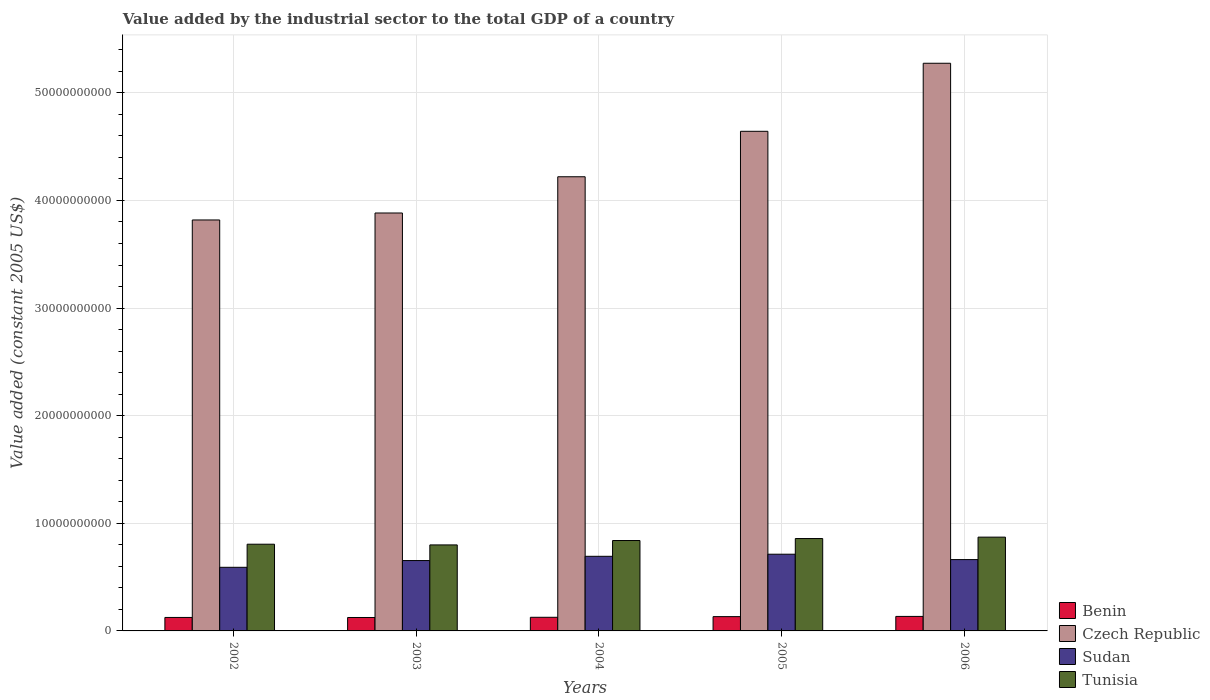How many different coloured bars are there?
Ensure brevity in your answer.  4. Are the number of bars on each tick of the X-axis equal?
Provide a succinct answer. Yes. How many bars are there on the 5th tick from the left?
Your answer should be compact. 4. How many bars are there on the 5th tick from the right?
Provide a succinct answer. 4. What is the label of the 2nd group of bars from the left?
Your answer should be compact. 2003. What is the value added by the industrial sector in Tunisia in 2003?
Provide a short and direct response. 7.99e+09. Across all years, what is the maximum value added by the industrial sector in Benin?
Offer a very short reply. 1.35e+09. Across all years, what is the minimum value added by the industrial sector in Benin?
Offer a very short reply. 1.25e+09. In which year was the value added by the industrial sector in Czech Republic maximum?
Give a very brief answer. 2006. What is the total value added by the industrial sector in Czech Republic in the graph?
Offer a terse response. 2.18e+11. What is the difference between the value added by the industrial sector in Tunisia in 2003 and that in 2005?
Provide a short and direct response. -5.93e+08. What is the difference between the value added by the industrial sector in Benin in 2005 and the value added by the industrial sector in Czech Republic in 2004?
Your answer should be compact. -4.09e+1. What is the average value added by the industrial sector in Sudan per year?
Make the answer very short. 6.63e+09. In the year 2005, what is the difference between the value added by the industrial sector in Sudan and value added by the industrial sector in Benin?
Provide a short and direct response. 5.80e+09. In how many years, is the value added by the industrial sector in Benin greater than 46000000000 US$?
Your answer should be very brief. 0. What is the ratio of the value added by the industrial sector in Benin in 2003 to that in 2006?
Ensure brevity in your answer.  0.93. Is the value added by the industrial sector in Czech Republic in 2003 less than that in 2004?
Give a very brief answer. Yes. What is the difference between the highest and the second highest value added by the industrial sector in Tunisia?
Your response must be concise. 1.30e+08. What is the difference between the highest and the lowest value added by the industrial sector in Benin?
Offer a very short reply. 1.00e+08. In how many years, is the value added by the industrial sector in Sudan greater than the average value added by the industrial sector in Sudan taken over all years?
Give a very brief answer. 3. Is the sum of the value added by the industrial sector in Sudan in 2003 and 2006 greater than the maximum value added by the industrial sector in Tunisia across all years?
Your response must be concise. Yes. Is it the case that in every year, the sum of the value added by the industrial sector in Tunisia and value added by the industrial sector in Benin is greater than the sum of value added by the industrial sector in Czech Republic and value added by the industrial sector in Sudan?
Your answer should be compact. Yes. What does the 3rd bar from the left in 2002 represents?
Provide a succinct answer. Sudan. What does the 4th bar from the right in 2002 represents?
Provide a short and direct response. Benin. Is it the case that in every year, the sum of the value added by the industrial sector in Tunisia and value added by the industrial sector in Benin is greater than the value added by the industrial sector in Czech Republic?
Your answer should be compact. No. How many bars are there?
Offer a very short reply. 20. How many years are there in the graph?
Your answer should be very brief. 5. What is the difference between two consecutive major ticks on the Y-axis?
Provide a short and direct response. 1.00e+1. Are the values on the major ticks of Y-axis written in scientific E-notation?
Offer a terse response. No. Does the graph contain any zero values?
Your answer should be very brief. No. How are the legend labels stacked?
Provide a short and direct response. Vertical. What is the title of the graph?
Ensure brevity in your answer.  Value added by the industrial sector to the total GDP of a country. Does "Nicaragua" appear as one of the legend labels in the graph?
Keep it short and to the point. No. What is the label or title of the X-axis?
Make the answer very short. Years. What is the label or title of the Y-axis?
Provide a succinct answer. Value added (constant 2005 US$). What is the Value added (constant 2005 US$) in Benin in 2002?
Provide a succinct answer. 1.25e+09. What is the Value added (constant 2005 US$) of Czech Republic in 2002?
Offer a terse response. 3.82e+1. What is the Value added (constant 2005 US$) of Sudan in 2002?
Provide a succinct answer. 5.91e+09. What is the Value added (constant 2005 US$) of Tunisia in 2002?
Your answer should be very brief. 8.06e+09. What is the Value added (constant 2005 US$) in Benin in 2003?
Your response must be concise. 1.25e+09. What is the Value added (constant 2005 US$) in Czech Republic in 2003?
Ensure brevity in your answer.  3.88e+1. What is the Value added (constant 2005 US$) in Sudan in 2003?
Your answer should be compact. 6.54e+09. What is the Value added (constant 2005 US$) of Tunisia in 2003?
Your answer should be compact. 7.99e+09. What is the Value added (constant 2005 US$) in Benin in 2004?
Ensure brevity in your answer.  1.27e+09. What is the Value added (constant 2005 US$) of Czech Republic in 2004?
Keep it short and to the point. 4.22e+1. What is the Value added (constant 2005 US$) of Sudan in 2004?
Make the answer very short. 6.93e+09. What is the Value added (constant 2005 US$) in Tunisia in 2004?
Provide a succinct answer. 8.40e+09. What is the Value added (constant 2005 US$) in Benin in 2005?
Give a very brief answer. 1.33e+09. What is the Value added (constant 2005 US$) in Czech Republic in 2005?
Give a very brief answer. 4.64e+1. What is the Value added (constant 2005 US$) of Sudan in 2005?
Give a very brief answer. 7.13e+09. What is the Value added (constant 2005 US$) in Tunisia in 2005?
Your answer should be very brief. 8.59e+09. What is the Value added (constant 2005 US$) of Benin in 2006?
Offer a terse response. 1.35e+09. What is the Value added (constant 2005 US$) in Czech Republic in 2006?
Provide a short and direct response. 5.28e+1. What is the Value added (constant 2005 US$) in Sudan in 2006?
Your answer should be compact. 6.63e+09. What is the Value added (constant 2005 US$) of Tunisia in 2006?
Keep it short and to the point. 8.72e+09. Across all years, what is the maximum Value added (constant 2005 US$) of Benin?
Ensure brevity in your answer.  1.35e+09. Across all years, what is the maximum Value added (constant 2005 US$) in Czech Republic?
Offer a very short reply. 5.28e+1. Across all years, what is the maximum Value added (constant 2005 US$) in Sudan?
Make the answer very short. 7.13e+09. Across all years, what is the maximum Value added (constant 2005 US$) of Tunisia?
Provide a short and direct response. 8.72e+09. Across all years, what is the minimum Value added (constant 2005 US$) in Benin?
Your answer should be compact. 1.25e+09. Across all years, what is the minimum Value added (constant 2005 US$) of Czech Republic?
Provide a succinct answer. 3.82e+1. Across all years, what is the minimum Value added (constant 2005 US$) of Sudan?
Your answer should be compact. 5.91e+09. Across all years, what is the minimum Value added (constant 2005 US$) of Tunisia?
Make the answer very short. 7.99e+09. What is the total Value added (constant 2005 US$) in Benin in the graph?
Make the answer very short. 6.44e+09. What is the total Value added (constant 2005 US$) of Czech Republic in the graph?
Offer a very short reply. 2.18e+11. What is the total Value added (constant 2005 US$) in Sudan in the graph?
Your response must be concise. 3.31e+1. What is the total Value added (constant 2005 US$) in Tunisia in the graph?
Your answer should be compact. 4.18e+1. What is the difference between the Value added (constant 2005 US$) in Benin in 2002 and that in 2003?
Your answer should be very brief. 4.56e+06. What is the difference between the Value added (constant 2005 US$) in Czech Republic in 2002 and that in 2003?
Give a very brief answer. -6.47e+08. What is the difference between the Value added (constant 2005 US$) of Sudan in 2002 and that in 2003?
Your answer should be very brief. -6.27e+08. What is the difference between the Value added (constant 2005 US$) in Tunisia in 2002 and that in 2003?
Make the answer very short. 6.48e+07. What is the difference between the Value added (constant 2005 US$) of Benin in 2002 and that in 2004?
Give a very brief answer. -1.42e+07. What is the difference between the Value added (constant 2005 US$) in Czech Republic in 2002 and that in 2004?
Offer a very short reply. -4.02e+09. What is the difference between the Value added (constant 2005 US$) in Sudan in 2002 and that in 2004?
Your answer should be very brief. -1.02e+09. What is the difference between the Value added (constant 2005 US$) of Tunisia in 2002 and that in 2004?
Provide a succinct answer. -3.43e+08. What is the difference between the Value added (constant 2005 US$) in Benin in 2002 and that in 2005?
Give a very brief answer. -7.57e+07. What is the difference between the Value added (constant 2005 US$) of Czech Republic in 2002 and that in 2005?
Your answer should be very brief. -8.24e+09. What is the difference between the Value added (constant 2005 US$) in Sudan in 2002 and that in 2005?
Offer a very short reply. -1.22e+09. What is the difference between the Value added (constant 2005 US$) of Tunisia in 2002 and that in 2005?
Make the answer very short. -5.28e+08. What is the difference between the Value added (constant 2005 US$) in Benin in 2002 and that in 2006?
Keep it short and to the point. -9.55e+07. What is the difference between the Value added (constant 2005 US$) of Czech Republic in 2002 and that in 2006?
Keep it short and to the point. -1.46e+1. What is the difference between the Value added (constant 2005 US$) of Sudan in 2002 and that in 2006?
Ensure brevity in your answer.  -7.18e+08. What is the difference between the Value added (constant 2005 US$) in Tunisia in 2002 and that in 2006?
Offer a very short reply. -6.58e+08. What is the difference between the Value added (constant 2005 US$) of Benin in 2003 and that in 2004?
Your response must be concise. -1.88e+07. What is the difference between the Value added (constant 2005 US$) of Czech Republic in 2003 and that in 2004?
Ensure brevity in your answer.  -3.37e+09. What is the difference between the Value added (constant 2005 US$) of Sudan in 2003 and that in 2004?
Provide a short and direct response. -3.95e+08. What is the difference between the Value added (constant 2005 US$) in Tunisia in 2003 and that in 2004?
Provide a short and direct response. -4.08e+08. What is the difference between the Value added (constant 2005 US$) in Benin in 2003 and that in 2005?
Keep it short and to the point. -8.03e+07. What is the difference between the Value added (constant 2005 US$) of Czech Republic in 2003 and that in 2005?
Your answer should be very brief. -7.59e+09. What is the difference between the Value added (constant 2005 US$) in Sudan in 2003 and that in 2005?
Keep it short and to the point. -5.90e+08. What is the difference between the Value added (constant 2005 US$) in Tunisia in 2003 and that in 2005?
Provide a short and direct response. -5.93e+08. What is the difference between the Value added (constant 2005 US$) of Benin in 2003 and that in 2006?
Give a very brief answer. -1.00e+08. What is the difference between the Value added (constant 2005 US$) of Czech Republic in 2003 and that in 2006?
Your response must be concise. -1.39e+1. What is the difference between the Value added (constant 2005 US$) in Sudan in 2003 and that in 2006?
Offer a terse response. -9.01e+07. What is the difference between the Value added (constant 2005 US$) in Tunisia in 2003 and that in 2006?
Offer a very short reply. -7.23e+08. What is the difference between the Value added (constant 2005 US$) in Benin in 2004 and that in 2005?
Keep it short and to the point. -6.15e+07. What is the difference between the Value added (constant 2005 US$) in Czech Republic in 2004 and that in 2005?
Your response must be concise. -4.22e+09. What is the difference between the Value added (constant 2005 US$) in Sudan in 2004 and that in 2005?
Provide a short and direct response. -1.94e+08. What is the difference between the Value added (constant 2005 US$) in Tunisia in 2004 and that in 2005?
Provide a short and direct response. -1.85e+08. What is the difference between the Value added (constant 2005 US$) in Benin in 2004 and that in 2006?
Offer a very short reply. -8.12e+07. What is the difference between the Value added (constant 2005 US$) in Czech Republic in 2004 and that in 2006?
Offer a very short reply. -1.05e+1. What is the difference between the Value added (constant 2005 US$) in Sudan in 2004 and that in 2006?
Provide a succinct answer. 3.05e+08. What is the difference between the Value added (constant 2005 US$) in Tunisia in 2004 and that in 2006?
Provide a short and direct response. -3.15e+08. What is the difference between the Value added (constant 2005 US$) of Benin in 2005 and that in 2006?
Provide a short and direct response. -1.97e+07. What is the difference between the Value added (constant 2005 US$) of Czech Republic in 2005 and that in 2006?
Provide a succinct answer. -6.32e+09. What is the difference between the Value added (constant 2005 US$) of Sudan in 2005 and that in 2006?
Ensure brevity in your answer.  5.00e+08. What is the difference between the Value added (constant 2005 US$) of Tunisia in 2005 and that in 2006?
Provide a succinct answer. -1.30e+08. What is the difference between the Value added (constant 2005 US$) of Benin in 2002 and the Value added (constant 2005 US$) of Czech Republic in 2003?
Your answer should be very brief. -3.76e+1. What is the difference between the Value added (constant 2005 US$) of Benin in 2002 and the Value added (constant 2005 US$) of Sudan in 2003?
Provide a short and direct response. -5.29e+09. What is the difference between the Value added (constant 2005 US$) of Benin in 2002 and the Value added (constant 2005 US$) of Tunisia in 2003?
Provide a short and direct response. -6.74e+09. What is the difference between the Value added (constant 2005 US$) of Czech Republic in 2002 and the Value added (constant 2005 US$) of Sudan in 2003?
Your answer should be compact. 3.17e+1. What is the difference between the Value added (constant 2005 US$) of Czech Republic in 2002 and the Value added (constant 2005 US$) of Tunisia in 2003?
Give a very brief answer. 3.02e+1. What is the difference between the Value added (constant 2005 US$) of Sudan in 2002 and the Value added (constant 2005 US$) of Tunisia in 2003?
Give a very brief answer. -2.08e+09. What is the difference between the Value added (constant 2005 US$) in Benin in 2002 and the Value added (constant 2005 US$) in Czech Republic in 2004?
Your answer should be very brief. -4.10e+1. What is the difference between the Value added (constant 2005 US$) in Benin in 2002 and the Value added (constant 2005 US$) in Sudan in 2004?
Offer a very short reply. -5.68e+09. What is the difference between the Value added (constant 2005 US$) in Benin in 2002 and the Value added (constant 2005 US$) in Tunisia in 2004?
Ensure brevity in your answer.  -7.15e+09. What is the difference between the Value added (constant 2005 US$) of Czech Republic in 2002 and the Value added (constant 2005 US$) of Sudan in 2004?
Ensure brevity in your answer.  3.13e+1. What is the difference between the Value added (constant 2005 US$) in Czech Republic in 2002 and the Value added (constant 2005 US$) in Tunisia in 2004?
Your response must be concise. 2.98e+1. What is the difference between the Value added (constant 2005 US$) of Sudan in 2002 and the Value added (constant 2005 US$) of Tunisia in 2004?
Offer a very short reply. -2.49e+09. What is the difference between the Value added (constant 2005 US$) in Benin in 2002 and the Value added (constant 2005 US$) in Czech Republic in 2005?
Ensure brevity in your answer.  -4.52e+1. What is the difference between the Value added (constant 2005 US$) of Benin in 2002 and the Value added (constant 2005 US$) of Sudan in 2005?
Offer a very short reply. -5.88e+09. What is the difference between the Value added (constant 2005 US$) in Benin in 2002 and the Value added (constant 2005 US$) in Tunisia in 2005?
Provide a short and direct response. -7.33e+09. What is the difference between the Value added (constant 2005 US$) of Czech Republic in 2002 and the Value added (constant 2005 US$) of Sudan in 2005?
Keep it short and to the point. 3.11e+1. What is the difference between the Value added (constant 2005 US$) in Czech Republic in 2002 and the Value added (constant 2005 US$) in Tunisia in 2005?
Ensure brevity in your answer.  2.96e+1. What is the difference between the Value added (constant 2005 US$) in Sudan in 2002 and the Value added (constant 2005 US$) in Tunisia in 2005?
Offer a very short reply. -2.67e+09. What is the difference between the Value added (constant 2005 US$) of Benin in 2002 and the Value added (constant 2005 US$) of Czech Republic in 2006?
Your answer should be very brief. -5.15e+1. What is the difference between the Value added (constant 2005 US$) in Benin in 2002 and the Value added (constant 2005 US$) in Sudan in 2006?
Provide a short and direct response. -5.38e+09. What is the difference between the Value added (constant 2005 US$) in Benin in 2002 and the Value added (constant 2005 US$) in Tunisia in 2006?
Give a very brief answer. -7.46e+09. What is the difference between the Value added (constant 2005 US$) in Czech Republic in 2002 and the Value added (constant 2005 US$) in Sudan in 2006?
Your response must be concise. 3.16e+1. What is the difference between the Value added (constant 2005 US$) in Czech Republic in 2002 and the Value added (constant 2005 US$) in Tunisia in 2006?
Your response must be concise. 2.95e+1. What is the difference between the Value added (constant 2005 US$) of Sudan in 2002 and the Value added (constant 2005 US$) of Tunisia in 2006?
Your response must be concise. -2.80e+09. What is the difference between the Value added (constant 2005 US$) in Benin in 2003 and the Value added (constant 2005 US$) in Czech Republic in 2004?
Your answer should be very brief. -4.10e+1. What is the difference between the Value added (constant 2005 US$) in Benin in 2003 and the Value added (constant 2005 US$) in Sudan in 2004?
Your answer should be compact. -5.69e+09. What is the difference between the Value added (constant 2005 US$) of Benin in 2003 and the Value added (constant 2005 US$) of Tunisia in 2004?
Your response must be concise. -7.15e+09. What is the difference between the Value added (constant 2005 US$) of Czech Republic in 2003 and the Value added (constant 2005 US$) of Sudan in 2004?
Offer a terse response. 3.19e+1. What is the difference between the Value added (constant 2005 US$) of Czech Republic in 2003 and the Value added (constant 2005 US$) of Tunisia in 2004?
Your answer should be very brief. 3.04e+1. What is the difference between the Value added (constant 2005 US$) in Sudan in 2003 and the Value added (constant 2005 US$) in Tunisia in 2004?
Keep it short and to the point. -1.86e+09. What is the difference between the Value added (constant 2005 US$) in Benin in 2003 and the Value added (constant 2005 US$) in Czech Republic in 2005?
Make the answer very short. -4.52e+1. What is the difference between the Value added (constant 2005 US$) of Benin in 2003 and the Value added (constant 2005 US$) of Sudan in 2005?
Provide a short and direct response. -5.88e+09. What is the difference between the Value added (constant 2005 US$) of Benin in 2003 and the Value added (constant 2005 US$) of Tunisia in 2005?
Provide a short and direct response. -7.34e+09. What is the difference between the Value added (constant 2005 US$) of Czech Republic in 2003 and the Value added (constant 2005 US$) of Sudan in 2005?
Provide a short and direct response. 3.17e+1. What is the difference between the Value added (constant 2005 US$) in Czech Republic in 2003 and the Value added (constant 2005 US$) in Tunisia in 2005?
Your answer should be very brief. 3.03e+1. What is the difference between the Value added (constant 2005 US$) in Sudan in 2003 and the Value added (constant 2005 US$) in Tunisia in 2005?
Provide a succinct answer. -2.05e+09. What is the difference between the Value added (constant 2005 US$) of Benin in 2003 and the Value added (constant 2005 US$) of Czech Republic in 2006?
Give a very brief answer. -5.15e+1. What is the difference between the Value added (constant 2005 US$) of Benin in 2003 and the Value added (constant 2005 US$) of Sudan in 2006?
Make the answer very short. -5.38e+09. What is the difference between the Value added (constant 2005 US$) in Benin in 2003 and the Value added (constant 2005 US$) in Tunisia in 2006?
Give a very brief answer. -7.47e+09. What is the difference between the Value added (constant 2005 US$) in Czech Republic in 2003 and the Value added (constant 2005 US$) in Sudan in 2006?
Your answer should be very brief. 3.22e+1. What is the difference between the Value added (constant 2005 US$) of Czech Republic in 2003 and the Value added (constant 2005 US$) of Tunisia in 2006?
Your answer should be compact. 3.01e+1. What is the difference between the Value added (constant 2005 US$) of Sudan in 2003 and the Value added (constant 2005 US$) of Tunisia in 2006?
Make the answer very short. -2.18e+09. What is the difference between the Value added (constant 2005 US$) in Benin in 2004 and the Value added (constant 2005 US$) in Czech Republic in 2005?
Keep it short and to the point. -4.52e+1. What is the difference between the Value added (constant 2005 US$) in Benin in 2004 and the Value added (constant 2005 US$) in Sudan in 2005?
Offer a very short reply. -5.86e+09. What is the difference between the Value added (constant 2005 US$) of Benin in 2004 and the Value added (constant 2005 US$) of Tunisia in 2005?
Make the answer very short. -7.32e+09. What is the difference between the Value added (constant 2005 US$) of Czech Republic in 2004 and the Value added (constant 2005 US$) of Sudan in 2005?
Provide a short and direct response. 3.51e+1. What is the difference between the Value added (constant 2005 US$) in Czech Republic in 2004 and the Value added (constant 2005 US$) in Tunisia in 2005?
Offer a terse response. 3.36e+1. What is the difference between the Value added (constant 2005 US$) of Sudan in 2004 and the Value added (constant 2005 US$) of Tunisia in 2005?
Your answer should be very brief. -1.65e+09. What is the difference between the Value added (constant 2005 US$) of Benin in 2004 and the Value added (constant 2005 US$) of Czech Republic in 2006?
Your answer should be compact. -5.15e+1. What is the difference between the Value added (constant 2005 US$) of Benin in 2004 and the Value added (constant 2005 US$) of Sudan in 2006?
Your response must be concise. -5.36e+09. What is the difference between the Value added (constant 2005 US$) in Benin in 2004 and the Value added (constant 2005 US$) in Tunisia in 2006?
Provide a short and direct response. -7.45e+09. What is the difference between the Value added (constant 2005 US$) of Czech Republic in 2004 and the Value added (constant 2005 US$) of Sudan in 2006?
Your answer should be compact. 3.56e+1. What is the difference between the Value added (constant 2005 US$) of Czech Republic in 2004 and the Value added (constant 2005 US$) of Tunisia in 2006?
Keep it short and to the point. 3.35e+1. What is the difference between the Value added (constant 2005 US$) in Sudan in 2004 and the Value added (constant 2005 US$) in Tunisia in 2006?
Keep it short and to the point. -1.78e+09. What is the difference between the Value added (constant 2005 US$) of Benin in 2005 and the Value added (constant 2005 US$) of Czech Republic in 2006?
Offer a very short reply. -5.14e+1. What is the difference between the Value added (constant 2005 US$) of Benin in 2005 and the Value added (constant 2005 US$) of Sudan in 2006?
Your response must be concise. -5.30e+09. What is the difference between the Value added (constant 2005 US$) in Benin in 2005 and the Value added (constant 2005 US$) in Tunisia in 2006?
Your response must be concise. -7.39e+09. What is the difference between the Value added (constant 2005 US$) of Czech Republic in 2005 and the Value added (constant 2005 US$) of Sudan in 2006?
Your answer should be compact. 3.98e+1. What is the difference between the Value added (constant 2005 US$) of Czech Republic in 2005 and the Value added (constant 2005 US$) of Tunisia in 2006?
Keep it short and to the point. 3.77e+1. What is the difference between the Value added (constant 2005 US$) of Sudan in 2005 and the Value added (constant 2005 US$) of Tunisia in 2006?
Give a very brief answer. -1.59e+09. What is the average Value added (constant 2005 US$) of Benin per year?
Provide a succinct answer. 1.29e+09. What is the average Value added (constant 2005 US$) in Czech Republic per year?
Ensure brevity in your answer.  4.37e+1. What is the average Value added (constant 2005 US$) in Sudan per year?
Provide a short and direct response. 6.63e+09. What is the average Value added (constant 2005 US$) in Tunisia per year?
Your answer should be very brief. 8.35e+09. In the year 2002, what is the difference between the Value added (constant 2005 US$) in Benin and Value added (constant 2005 US$) in Czech Republic?
Offer a terse response. -3.69e+1. In the year 2002, what is the difference between the Value added (constant 2005 US$) of Benin and Value added (constant 2005 US$) of Sudan?
Provide a succinct answer. -4.66e+09. In the year 2002, what is the difference between the Value added (constant 2005 US$) in Benin and Value added (constant 2005 US$) in Tunisia?
Provide a short and direct response. -6.81e+09. In the year 2002, what is the difference between the Value added (constant 2005 US$) of Czech Republic and Value added (constant 2005 US$) of Sudan?
Offer a very short reply. 3.23e+1. In the year 2002, what is the difference between the Value added (constant 2005 US$) of Czech Republic and Value added (constant 2005 US$) of Tunisia?
Ensure brevity in your answer.  3.01e+1. In the year 2002, what is the difference between the Value added (constant 2005 US$) of Sudan and Value added (constant 2005 US$) of Tunisia?
Offer a terse response. -2.15e+09. In the year 2003, what is the difference between the Value added (constant 2005 US$) in Benin and Value added (constant 2005 US$) in Czech Republic?
Give a very brief answer. -3.76e+1. In the year 2003, what is the difference between the Value added (constant 2005 US$) in Benin and Value added (constant 2005 US$) in Sudan?
Your answer should be compact. -5.29e+09. In the year 2003, what is the difference between the Value added (constant 2005 US$) in Benin and Value added (constant 2005 US$) in Tunisia?
Offer a very short reply. -6.74e+09. In the year 2003, what is the difference between the Value added (constant 2005 US$) in Czech Republic and Value added (constant 2005 US$) in Sudan?
Offer a very short reply. 3.23e+1. In the year 2003, what is the difference between the Value added (constant 2005 US$) of Czech Republic and Value added (constant 2005 US$) of Tunisia?
Your response must be concise. 3.08e+1. In the year 2003, what is the difference between the Value added (constant 2005 US$) of Sudan and Value added (constant 2005 US$) of Tunisia?
Your answer should be compact. -1.45e+09. In the year 2004, what is the difference between the Value added (constant 2005 US$) of Benin and Value added (constant 2005 US$) of Czech Republic?
Keep it short and to the point. -4.09e+1. In the year 2004, what is the difference between the Value added (constant 2005 US$) in Benin and Value added (constant 2005 US$) in Sudan?
Keep it short and to the point. -5.67e+09. In the year 2004, what is the difference between the Value added (constant 2005 US$) of Benin and Value added (constant 2005 US$) of Tunisia?
Ensure brevity in your answer.  -7.13e+09. In the year 2004, what is the difference between the Value added (constant 2005 US$) of Czech Republic and Value added (constant 2005 US$) of Sudan?
Ensure brevity in your answer.  3.53e+1. In the year 2004, what is the difference between the Value added (constant 2005 US$) of Czech Republic and Value added (constant 2005 US$) of Tunisia?
Provide a short and direct response. 3.38e+1. In the year 2004, what is the difference between the Value added (constant 2005 US$) of Sudan and Value added (constant 2005 US$) of Tunisia?
Your answer should be very brief. -1.47e+09. In the year 2005, what is the difference between the Value added (constant 2005 US$) in Benin and Value added (constant 2005 US$) in Czech Republic?
Make the answer very short. -4.51e+1. In the year 2005, what is the difference between the Value added (constant 2005 US$) in Benin and Value added (constant 2005 US$) in Sudan?
Ensure brevity in your answer.  -5.80e+09. In the year 2005, what is the difference between the Value added (constant 2005 US$) in Benin and Value added (constant 2005 US$) in Tunisia?
Give a very brief answer. -7.26e+09. In the year 2005, what is the difference between the Value added (constant 2005 US$) in Czech Republic and Value added (constant 2005 US$) in Sudan?
Offer a terse response. 3.93e+1. In the year 2005, what is the difference between the Value added (constant 2005 US$) of Czech Republic and Value added (constant 2005 US$) of Tunisia?
Your answer should be compact. 3.78e+1. In the year 2005, what is the difference between the Value added (constant 2005 US$) of Sudan and Value added (constant 2005 US$) of Tunisia?
Provide a succinct answer. -1.46e+09. In the year 2006, what is the difference between the Value added (constant 2005 US$) of Benin and Value added (constant 2005 US$) of Czech Republic?
Make the answer very short. -5.14e+1. In the year 2006, what is the difference between the Value added (constant 2005 US$) of Benin and Value added (constant 2005 US$) of Sudan?
Provide a short and direct response. -5.28e+09. In the year 2006, what is the difference between the Value added (constant 2005 US$) of Benin and Value added (constant 2005 US$) of Tunisia?
Keep it short and to the point. -7.37e+09. In the year 2006, what is the difference between the Value added (constant 2005 US$) of Czech Republic and Value added (constant 2005 US$) of Sudan?
Offer a very short reply. 4.61e+1. In the year 2006, what is the difference between the Value added (constant 2005 US$) of Czech Republic and Value added (constant 2005 US$) of Tunisia?
Keep it short and to the point. 4.40e+1. In the year 2006, what is the difference between the Value added (constant 2005 US$) in Sudan and Value added (constant 2005 US$) in Tunisia?
Provide a short and direct response. -2.09e+09. What is the ratio of the Value added (constant 2005 US$) of Benin in 2002 to that in 2003?
Your response must be concise. 1. What is the ratio of the Value added (constant 2005 US$) of Czech Republic in 2002 to that in 2003?
Offer a terse response. 0.98. What is the ratio of the Value added (constant 2005 US$) in Sudan in 2002 to that in 2003?
Offer a very short reply. 0.9. What is the ratio of the Value added (constant 2005 US$) in Czech Republic in 2002 to that in 2004?
Your response must be concise. 0.9. What is the ratio of the Value added (constant 2005 US$) of Sudan in 2002 to that in 2004?
Provide a short and direct response. 0.85. What is the ratio of the Value added (constant 2005 US$) in Tunisia in 2002 to that in 2004?
Your answer should be compact. 0.96. What is the ratio of the Value added (constant 2005 US$) in Benin in 2002 to that in 2005?
Your response must be concise. 0.94. What is the ratio of the Value added (constant 2005 US$) in Czech Republic in 2002 to that in 2005?
Offer a very short reply. 0.82. What is the ratio of the Value added (constant 2005 US$) of Sudan in 2002 to that in 2005?
Ensure brevity in your answer.  0.83. What is the ratio of the Value added (constant 2005 US$) of Tunisia in 2002 to that in 2005?
Provide a short and direct response. 0.94. What is the ratio of the Value added (constant 2005 US$) in Benin in 2002 to that in 2006?
Offer a terse response. 0.93. What is the ratio of the Value added (constant 2005 US$) of Czech Republic in 2002 to that in 2006?
Provide a succinct answer. 0.72. What is the ratio of the Value added (constant 2005 US$) in Sudan in 2002 to that in 2006?
Offer a terse response. 0.89. What is the ratio of the Value added (constant 2005 US$) of Tunisia in 2002 to that in 2006?
Keep it short and to the point. 0.92. What is the ratio of the Value added (constant 2005 US$) in Benin in 2003 to that in 2004?
Provide a succinct answer. 0.99. What is the ratio of the Value added (constant 2005 US$) in Czech Republic in 2003 to that in 2004?
Provide a succinct answer. 0.92. What is the ratio of the Value added (constant 2005 US$) of Sudan in 2003 to that in 2004?
Keep it short and to the point. 0.94. What is the ratio of the Value added (constant 2005 US$) of Tunisia in 2003 to that in 2004?
Provide a succinct answer. 0.95. What is the ratio of the Value added (constant 2005 US$) of Benin in 2003 to that in 2005?
Make the answer very short. 0.94. What is the ratio of the Value added (constant 2005 US$) of Czech Republic in 2003 to that in 2005?
Keep it short and to the point. 0.84. What is the ratio of the Value added (constant 2005 US$) in Sudan in 2003 to that in 2005?
Ensure brevity in your answer.  0.92. What is the ratio of the Value added (constant 2005 US$) of Tunisia in 2003 to that in 2005?
Offer a very short reply. 0.93. What is the ratio of the Value added (constant 2005 US$) of Benin in 2003 to that in 2006?
Ensure brevity in your answer.  0.93. What is the ratio of the Value added (constant 2005 US$) in Czech Republic in 2003 to that in 2006?
Your response must be concise. 0.74. What is the ratio of the Value added (constant 2005 US$) in Sudan in 2003 to that in 2006?
Offer a very short reply. 0.99. What is the ratio of the Value added (constant 2005 US$) in Tunisia in 2003 to that in 2006?
Ensure brevity in your answer.  0.92. What is the ratio of the Value added (constant 2005 US$) of Benin in 2004 to that in 2005?
Your answer should be very brief. 0.95. What is the ratio of the Value added (constant 2005 US$) of Czech Republic in 2004 to that in 2005?
Give a very brief answer. 0.91. What is the ratio of the Value added (constant 2005 US$) of Sudan in 2004 to that in 2005?
Offer a very short reply. 0.97. What is the ratio of the Value added (constant 2005 US$) of Tunisia in 2004 to that in 2005?
Ensure brevity in your answer.  0.98. What is the ratio of the Value added (constant 2005 US$) in Benin in 2004 to that in 2006?
Your answer should be compact. 0.94. What is the ratio of the Value added (constant 2005 US$) of Czech Republic in 2004 to that in 2006?
Your response must be concise. 0.8. What is the ratio of the Value added (constant 2005 US$) in Sudan in 2004 to that in 2006?
Keep it short and to the point. 1.05. What is the ratio of the Value added (constant 2005 US$) of Tunisia in 2004 to that in 2006?
Keep it short and to the point. 0.96. What is the ratio of the Value added (constant 2005 US$) in Benin in 2005 to that in 2006?
Provide a succinct answer. 0.99. What is the ratio of the Value added (constant 2005 US$) in Czech Republic in 2005 to that in 2006?
Your response must be concise. 0.88. What is the ratio of the Value added (constant 2005 US$) in Sudan in 2005 to that in 2006?
Ensure brevity in your answer.  1.08. What is the ratio of the Value added (constant 2005 US$) in Tunisia in 2005 to that in 2006?
Offer a very short reply. 0.99. What is the difference between the highest and the second highest Value added (constant 2005 US$) of Benin?
Provide a short and direct response. 1.97e+07. What is the difference between the highest and the second highest Value added (constant 2005 US$) in Czech Republic?
Ensure brevity in your answer.  6.32e+09. What is the difference between the highest and the second highest Value added (constant 2005 US$) in Sudan?
Your answer should be very brief. 1.94e+08. What is the difference between the highest and the second highest Value added (constant 2005 US$) in Tunisia?
Provide a succinct answer. 1.30e+08. What is the difference between the highest and the lowest Value added (constant 2005 US$) of Benin?
Provide a succinct answer. 1.00e+08. What is the difference between the highest and the lowest Value added (constant 2005 US$) in Czech Republic?
Your answer should be compact. 1.46e+1. What is the difference between the highest and the lowest Value added (constant 2005 US$) in Sudan?
Offer a terse response. 1.22e+09. What is the difference between the highest and the lowest Value added (constant 2005 US$) in Tunisia?
Ensure brevity in your answer.  7.23e+08. 